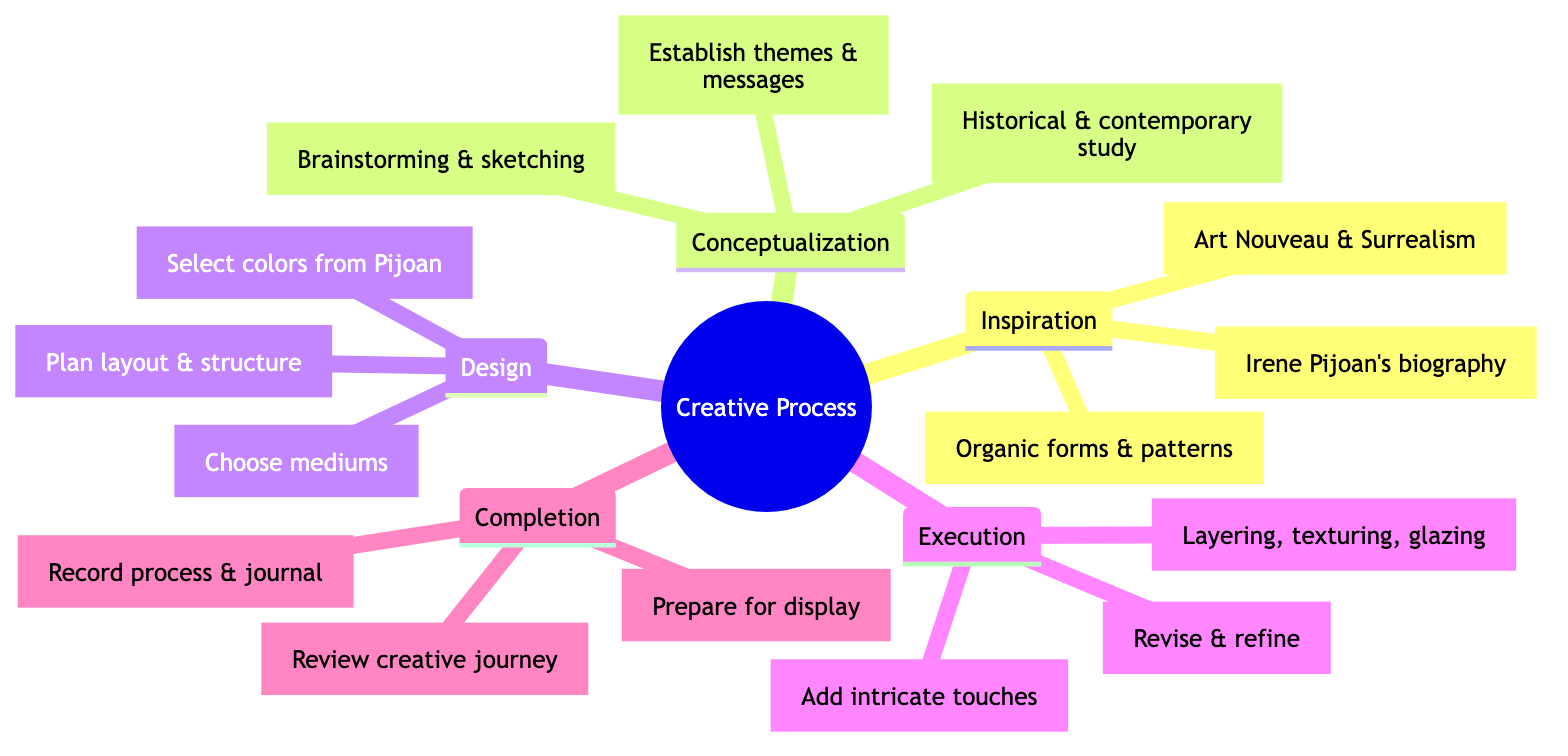What are the three main categories in the creative process? The diagram lists five main categories under the creative process: Inspiration, Conceptualization, Design, Execution, and Completion. However, if only three are needed, the answer should include Inspiration, Conceptualization, and Design as significant starting points.
Answer: Inspiration, Conceptualization, Design How many sub-nodes are there under the Design category? The Design category includes three sub-nodes: Composition, ColorPalette, and MaterialSelection. Counting these gives a total of three sub-nodes under Design.
Answer: 3 What technique involves revising and refining the artwork? The Execution category specifies Iteration as the technique that entails revising and refining the artwork by integrating feedback and self-assessment.
Answer: Iteration Which category discusses choosing mediums like paint or clay? Under the Design category, the sub-node MaterialSelection directly refers to choosing mediums that can include paint, clay, or digital tools for creating artwork.
Answer: MaterialSelection What is the final stage of the creative process? The Completion category is the last stage mentioned in the creative process, focusing on finalizing and reflecting on the artwork created.
Answer: Completion How many elements from Irene Pijoan's influences are listed under Inspiration? There are three elements listed under Inspiration: LifeEvents, ArtMovements, and Nature, highlighting Pijoan's biography, influences from Art Nouveau and Surrealism, and her observations of nature.
Answer: 3 What does the sub-node ThemeDefinition focus on? The ThemeDefinition sub-node under Conceptualization is concerned with establishing major themes and messages in the artwork being developed.
Answer: Establishing themes and messages Which category includes preparing the artwork for display? The Completion category is specified to include Presentation as the process of preparing the artwork for either display or publication purposes.
Answer: Presentation What is an example of a technique mentioned in the Execution category? Layering is mentioned as a technique within the Execution category, alongside other techniques such as texturing and glazing, used during the creation of the artwork.
Answer: Layering 